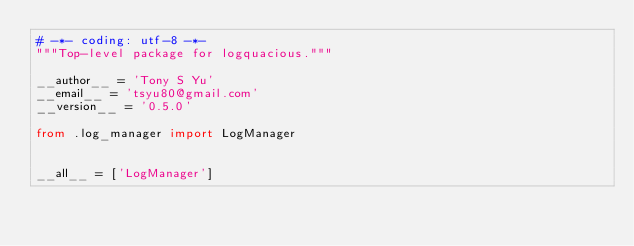<code> <loc_0><loc_0><loc_500><loc_500><_Python_># -*- coding: utf-8 -*-
"""Top-level package for logquacious."""

__author__ = 'Tony S Yu'
__email__ = 'tsyu80@gmail.com'
__version__ = '0.5.0'

from .log_manager import LogManager


__all__ = ['LogManager']
</code> 